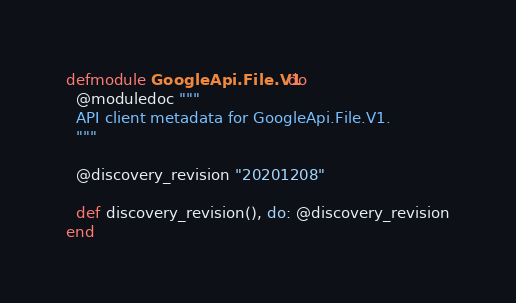Convert code to text. <code><loc_0><loc_0><loc_500><loc_500><_Elixir_>defmodule GoogleApi.File.V1 do
  @moduledoc """
  API client metadata for GoogleApi.File.V1.
  """

  @discovery_revision "20201208"

  def discovery_revision(), do: @discovery_revision
end
</code> 